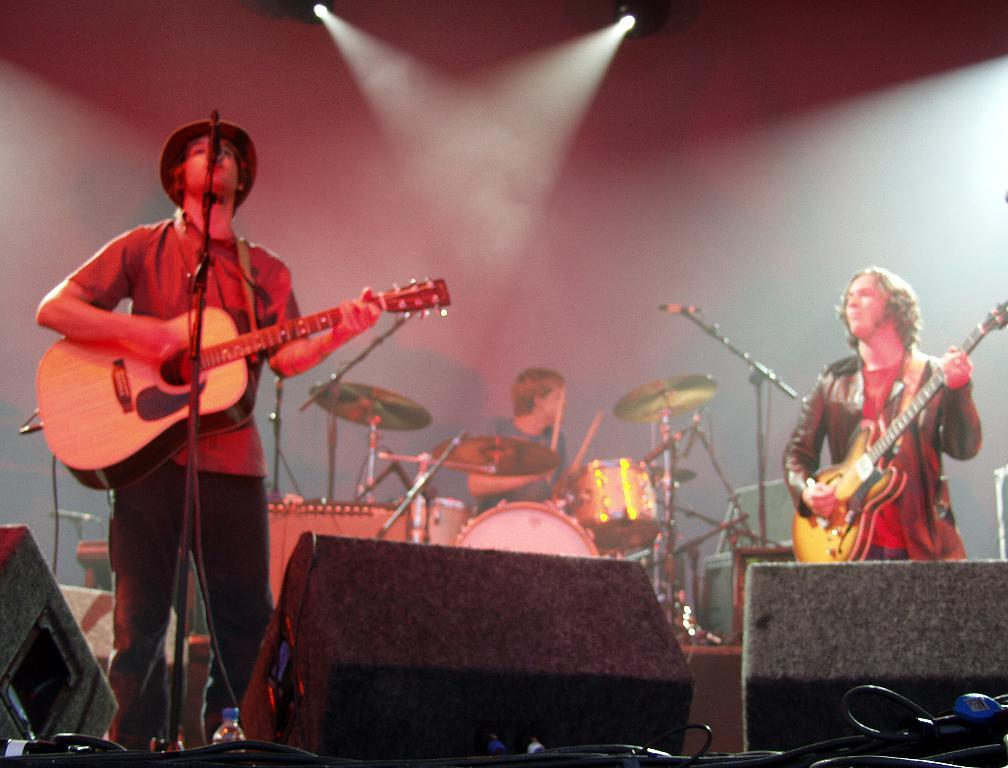What is the person wearing in the image? The person is wearing a red dress in the image. What is the person in the red dress doing? The person in the red dress is playing a guitar and singing. What object is present in the image that is commonly used for amplifying sound? There is a microphone in the image. How many people are playing musical instruments in the image? There are two people playing musical instruments in the image: one person on the right side of the image and another person in the back of the image playing drums. Can you see a donkey in the image? No, there is no donkey present in the image. What type of ball is being used by the person in the red dress while playing the guitar? There is no ball visible in the image; the person in the red dress is playing a guitar and singing. 